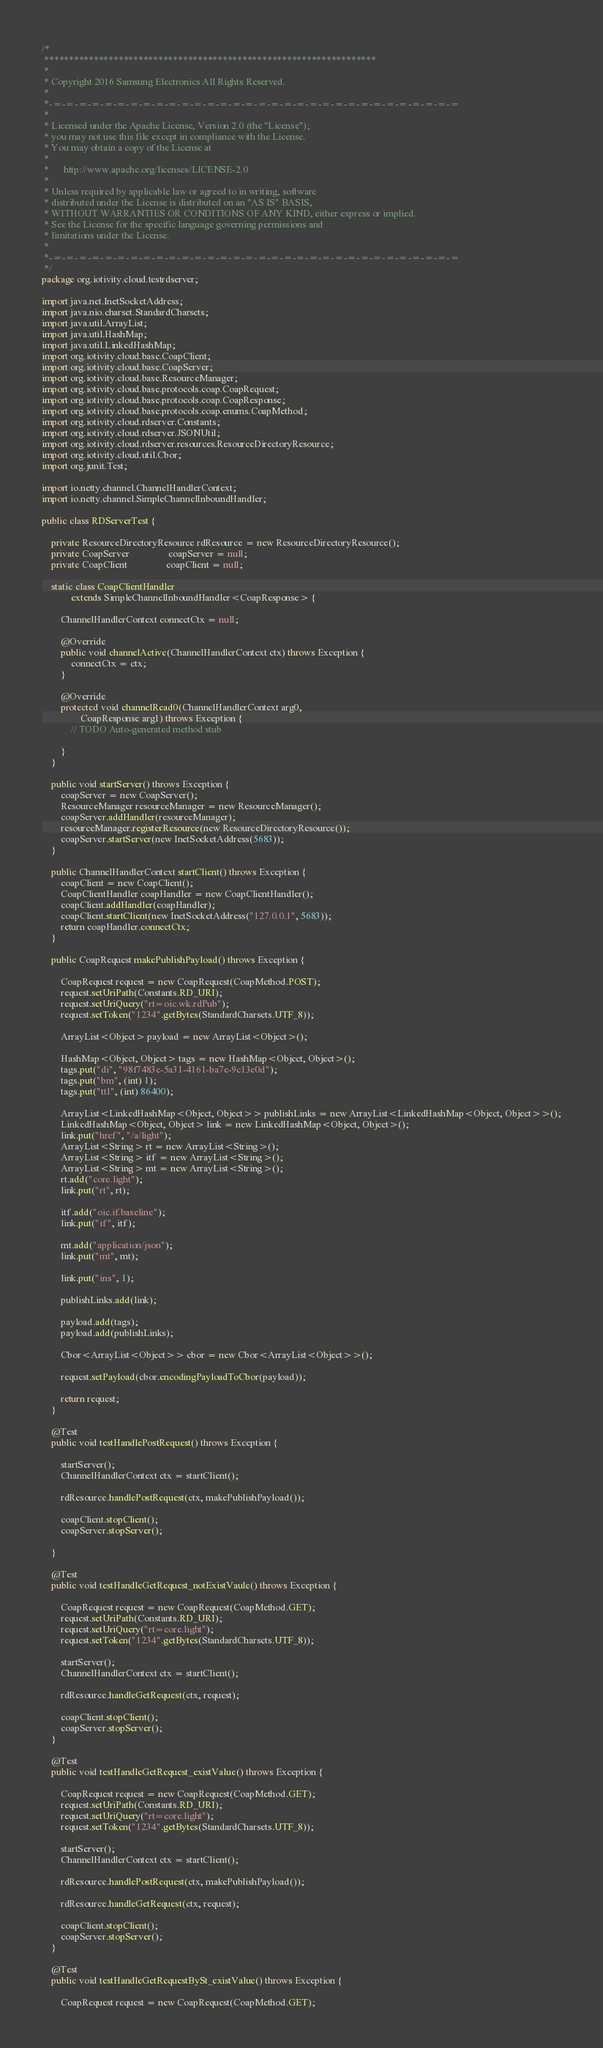Convert code to text. <code><loc_0><loc_0><loc_500><loc_500><_Java_>/*
 *******************************************************************
 *
 * Copyright 2016 Samsung Electronics All Rights Reserved.
 *
 *-=-=-=-=-=-=-=-=-=-=-=-=-=-=-=-=-=-=-=-=-=-=-=-=-=-=-=-=-=-=-=-=
 *
 * Licensed under the Apache License, Version 2.0 (the "License");
 * you may not use this file except in compliance with the License.
 * You may obtain a copy of the License at
 *
 *      http://www.apache.org/licenses/LICENSE-2.0
 *
 * Unless required by applicable law or agreed to in writing, software
 * distributed under the License is distributed on an "AS IS" BASIS,
 * WITHOUT WARRANTIES OR CONDITIONS OF ANY KIND, either express or implied.
 * See the License for the specific language governing permissions and
 * limitations under the License.
 *
 *-=-=-=-=-=-=-=-=-=-=-=-=-=-=-=-=-=-=-=-=-=-=-=-=-=-=-=-=-=-=-=-=
 */
package org.iotivity.cloud.testrdserver;

import java.net.InetSocketAddress;
import java.nio.charset.StandardCharsets;
import java.util.ArrayList;
import java.util.HashMap;
import java.util.LinkedHashMap;
import org.iotivity.cloud.base.CoapClient;
import org.iotivity.cloud.base.CoapServer;
import org.iotivity.cloud.base.ResourceManager;
import org.iotivity.cloud.base.protocols.coap.CoapRequest;
import org.iotivity.cloud.base.protocols.coap.CoapResponse;
import org.iotivity.cloud.base.protocols.coap.enums.CoapMethod;
import org.iotivity.cloud.rdserver.Constants;
import org.iotivity.cloud.rdserver.JSONUtil;
import org.iotivity.cloud.rdserver.resources.ResourceDirectoryResource;
import org.iotivity.cloud.util.Cbor;
import org.junit.Test;

import io.netty.channel.ChannelHandlerContext;
import io.netty.channel.SimpleChannelInboundHandler;

public class RDServerTest {

    private ResourceDirectoryResource rdResource = new ResourceDirectoryResource();
    private CoapServer                coapServer = null;
    private CoapClient                coapClient = null;

    static class CoapClientHandler
            extends SimpleChannelInboundHandler<CoapResponse> {

        ChannelHandlerContext connectCtx = null;

        @Override
        public void channelActive(ChannelHandlerContext ctx) throws Exception {
            connectCtx = ctx;
        }

        @Override
        protected void channelRead0(ChannelHandlerContext arg0,
                CoapResponse arg1) throws Exception {
            // TODO Auto-generated method stub

        }
    }

    public void startServer() throws Exception {
        coapServer = new CoapServer();
        ResourceManager resourceManager = new ResourceManager();
        coapServer.addHandler(resourceManager);
        resourceManager.registerResource(new ResourceDirectoryResource());
        coapServer.startServer(new InetSocketAddress(5683));
    }

    public ChannelHandlerContext startClient() throws Exception {
        coapClient = new CoapClient();
        CoapClientHandler coapHandler = new CoapClientHandler();
        coapClient.addHandler(coapHandler);
        coapClient.startClient(new InetSocketAddress("127.0.0.1", 5683));
        return coapHandler.connectCtx;
    }

    public CoapRequest makePublishPayload() throws Exception {

        CoapRequest request = new CoapRequest(CoapMethod.POST);
        request.setUriPath(Constants.RD_URI);
        request.setUriQuery("rt=oic.wk.rdPub");
        request.setToken("1234".getBytes(StandardCharsets.UTF_8));

        ArrayList<Object> payload = new ArrayList<Object>();

        HashMap<Object, Object> tags = new HashMap<Object, Object>();
        tags.put("di", "98f7483c-5a31-4161-ba7e-9c13e0d");
        tags.put("bm", (int) 1);
        tags.put("ttl", (int) 86400);

        ArrayList<LinkedHashMap<Object, Object>> publishLinks = new ArrayList<LinkedHashMap<Object, Object>>();
        LinkedHashMap<Object, Object> link = new LinkedHashMap<Object, Object>();
        link.put("href", "/a/light");
        ArrayList<String> rt = new ArrayList<String>();
        ArrayList<String> itf = new ArrayList<String>();
        ArrayList<String> mt = new ArrayList<String>();
        rt.add("core.light");
        link.put("rt", rt);

        itf.add("oic.if.baseline");
        link.put("if", itf);

        mt.add("application/json");
        link.put("mt", mt);

        link.put("ins", 1);

        publishLinks.add(link);

        payload.add(tags);
        payload.add(publishLinks);

        Cbor<ArrayList<Object>> cbor = new Cbor<ArrayList<Object>>();

        request.setPayload(cbor.encodingPayloadToCbor(payload));

        return request;
    }

    @Test
    public void testHandlePostRequest() throws Exception {

        startServer();
        ChannelHandlerContext ctx = startClient();

        rdResource.handlePostRequest(ctx, makePublishPayload());

        coapClient.stopClient();
        coapServer.stopServer();

    }

    @Test
    public void testHandleGetRequest_notExistVaule() throws Exception {

        CoapRequest request = new CoapRequest(CoapMethod.GET);
        request.setUriPath(Constants.RD_URI);
        request.setUriQuery("rt=core.light");
        request.setToken("1234".getBytes(StandardCharsets.UTF_8));

        startServer();
        ChannelHandlerContext ctx = startClient();

        rdResource.handleGetRequest(ctx, request);

        coapClient.stopClient();
        coapServer.stopServer();
    }

    @Test
    public void testHandleGetRequest_existValue() throws Exception {

        CoapRequest request = new CoapRequest(CoapMethod.GET);
        request.setUriPath(Constants.RD_URI);
        request.setUriQuery("rt=core.light");
        request.setToken("1234".getBytes(StandardCharsets.UTF_8));

        startServer();
        ChannelHandlerContext ctx = startClient();

        rdResource.handlePostRequest(ctx, makePublishPayload());

        rdResource.handleGetRequest(ctx, request);

        coapClient.stopClient();
        coapServer.stopServer();
    }

    @Test
    public void testHandleGetRequestBySt_existValue() throws Exception {

        CoapRequest request = new CoapRequest(CoapMethod.GET);</code> 